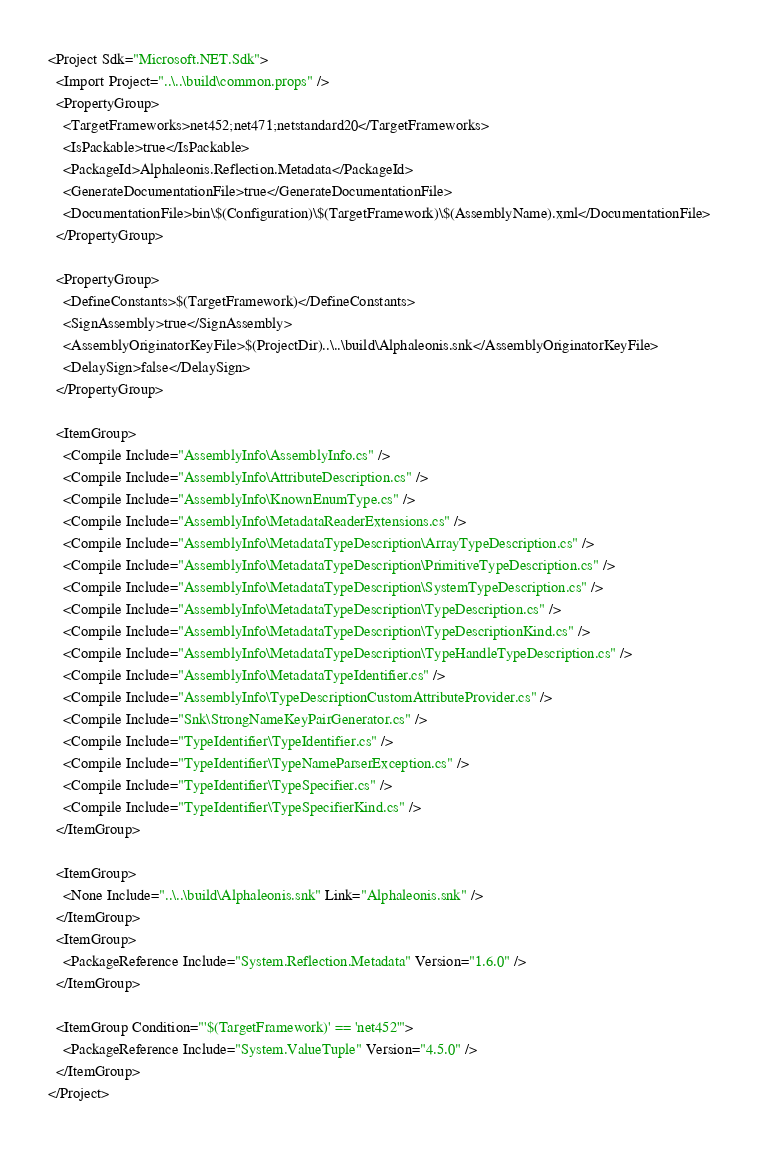<code> <loc_0><loc_0><loc_500><loc_500><_XML_><Project Sdk="Microsoft.NET.Sdk">
  <Import Project="..\..\build\common.props" />
  <PropertyGroup>
    <TargetFrameworks>net452;net471;netstandard20</TargetFrameworks>    
    <IsPackable>true</IsPackable>
    <PackageId>Alphaleonis.Reflection.Metadata</PackageId>
    <GenerateDocumentationFile>true</GenerateDocumentationFile>
    <DocumentationFile>bin\$(Configuration)\$(TargetFramework)\$(AssemblyName).xml</DocumentationFile>
  </PropertyGroup>

  <PropertyGroup>
    <DefineConstants>$(TargetFramework)</DefineConstants>
    <SignAssembly>true</SignAssembly>
    <AssemblyOriginatorKeyFile>$(ProjectDir)..\..\build\Alphaleonis.snk</AssemblyOriginatorKeyFile>
    <DelaySign>false</DelaySign>
  </PropertyGroup>

  <ItemGroup>
    <Compile Include="AssemblyInfo\AssemblyInfo.cs" />
    <Compile Include="AssemblyInfo\AttributeDescription.cs" />
    <Compile Include="AssemblyInfo\KnownEnumType.cs" />
    <Compile Include="AssemblyInfo\MetadataReaderExtensions.cs" />
    <Compile Include="AssemblyInfo\MetadataTypeDescription\ArrayTypeDescription.cs" />
    <Compile Include="AssemblyInfo\MetadataTypeDescription\PrimitiveTypeDescription.cs" />
    <Compile Include="AssemblyInfo\MetadataTypeDescription\SystemTypeDescription.cs" />
    <Compile Include="AssemblyInfo\MetadataTypeDescription\TypeDescription.cs" />
    <Compile Include="AssemblyInfo\MetadataTypeDescription\TypeDescriptionKind.cs" />
    <Compile Include="AssemblyInfo\MetadataTypeDescription\TypeHandleTypeDescription.cs" />
    <Compile Include="AssemblyInfo\MetadataTypeIdentifier.cs" />
    <Compile Include="AssemblyInfo\TypeDescriptionCustomAttributeProvider.cs" />
    <Compile Include="Snk\StrongNameKeyPairGenerator.cs" />
    <Compile Include="TypeIdentifier\TypeIdentifier.cs" />
    <Compile Include="TypeIdentifier\TypeNameParserException.cs" />
    <Compile Include="TypeIdentifier\TypeSpecifier.cs" />
    <Compile Include="TypeIdentifier\TypeSpecifierKind.cs" />
  </ItemGroup>

  <ItemGroup>
    <None Include="..\..\build\Alphaleonis.snk" Link="Alphaleonis.snk" />
  </ItemGroup>
  <ItemGroup>
    <PackageReference Include="System.Reflection.Metadata" Version="1.6.0" />
  </ItemGroup>

  <ItemGroup Condition="'$(TargetFramework)' == 'net452'">
    <PackageReference Include="System.ValueTuple" Version="4.5.0" />
  </ItemGroup>
</Project>
</code> 